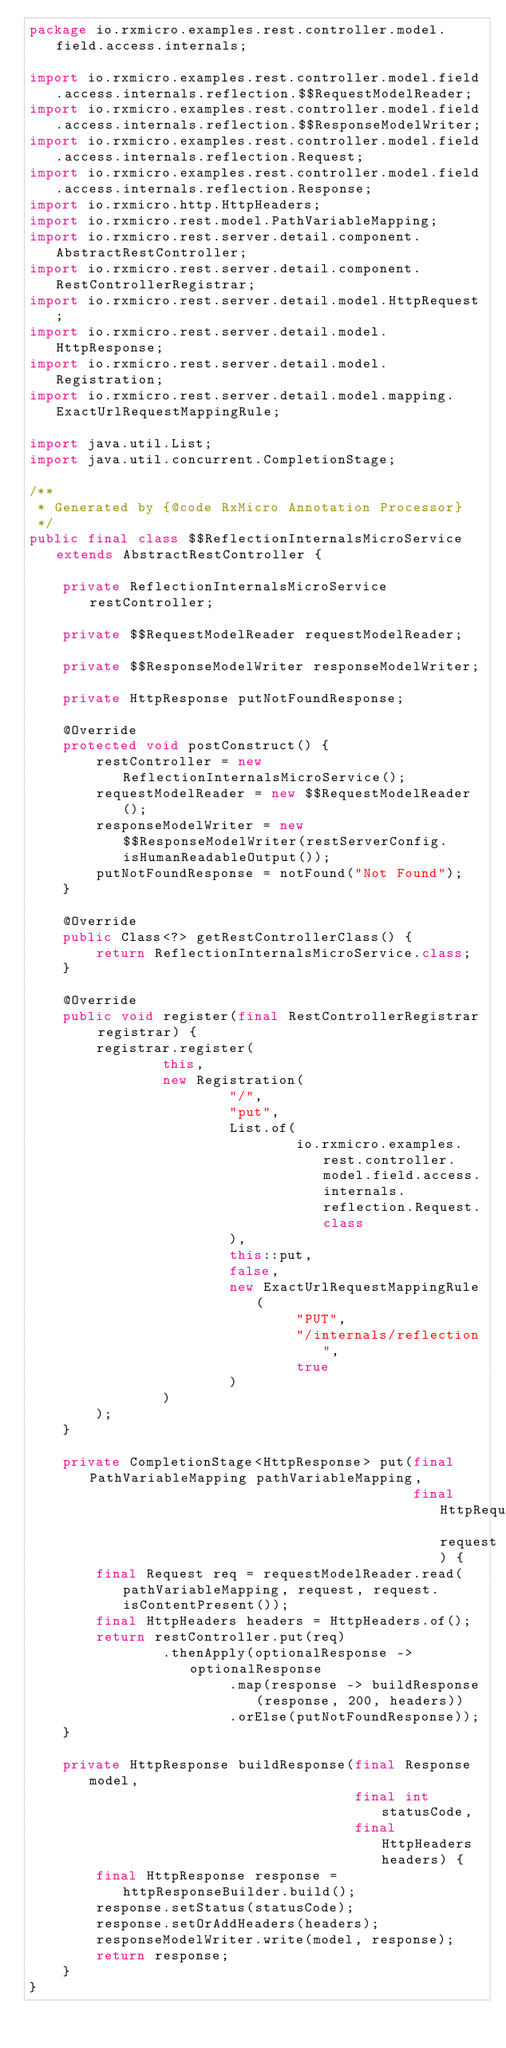Convert code to text. <code><loc_0><loc_0><loc_500><loc_500><_Java_>package io.rxmicro.examples.rest.controller.model.field.access.internals;

import io.rxmicro.examples.rest.controller.model.field.access.internals.reflection.$$RequestModelReader;
import io.rxmicro.examples.rest.controller.model.field.access.internals.reflection.$$ResponseModelWriter;
import io.rxmicro.examples.rest.controller.model.field.access.internals.reflection.Request;
import io.rxmicro.examples.rest.controller.model.field.access.internals.reflection.Response;
import io.rxmicro.http.HttpHeaders;
import io.rxmicro.rest.model.PathVariableMapping;
import io.rxmicro.rest.server.detail.component.AbstractRestController;
import io.rxmicro.rest.server.detail.component.RestControllerRegistrar;
import io.rxmicro.rest.server.detail.model.HttpRequest;
import io.rxmicro.rest.server.detail.model.HttpResponse;
import io.rxmicro.rest.server.detail.model.Registration;
import io.rxmicro.rest.server.detail.model.mapping.ExactUrlRequestMappingRule;

import java.util.List;
import java.util.concurrent.CompletionStage;

/**
 * Generated by {@code RxMicro Annotation Processor}
 */
public final class $$ReflectionInternalsMicroService extends AbstractRestController {

    private ReflectionInternalsMicroService restController;

    private $$RequestModelReader requestModelReader;

    private $$ResponseModelWriter responseModelWriter;

    private HttpResponse putNotFoundResponse;

    @Override
    protected void postConstruct() {
        restController = new ReflectionInternalsMicroService();
        requestModelReader = new $$RequestModelReader();
        responseModelWriter = new $$ResponseModelWriter(restServerConfig.isHumanReadableOutput());
        putNotFoundResponse = notFound("Not Found");
    }

    @Override
    public Class<?> getRestControllerClass() {
        return ReflectionInternalsMicroService.class;
    }

    @Override
    public void register(final RestControllerRegistrar registrar) {
        registrar.register(
                this,
                new Registration(
                        "/",
                        "put",
                        List.of(
                                io.rxmicro.examples.rest.controller.model.field.access.internals.reflection.Request.class
                        ),
                        this::put,
                        false,
                        new ExactUrlRequestMappingRule(
                                "PUT",
                                "/internals/reflection",
                                true
                        )
                )
        );
    }

    private CompletionStage<HttpResponse> put(final PathVariableMapping pathVariableMapping,
                                              final HttpRequest request) {
        final Request req = requestModelReader.read(pathVariableMapping, request, request.isContentPresent());
        final HttpHeaders headers = HttpHeaders.of();
        return restController.put(req)
                .thenApply(optionalResponse -> optionalResponse
                        .map(response -> buildResponse(response, 200, headers))
                        .orElse(putNotFoundResponse));
    }

    private HttpResponse buildResponse(final Response model,
                                       final int statusCode,
                                       final HttpHeaders headers) {
        final HttpResponse response = httpResponseBuilder.build();
        response.setStatus(statusCode);
        response.setOrAddHeaders(headers);
        responseModelWriter.write(model, response);
        return response;
    }
}
</code> 